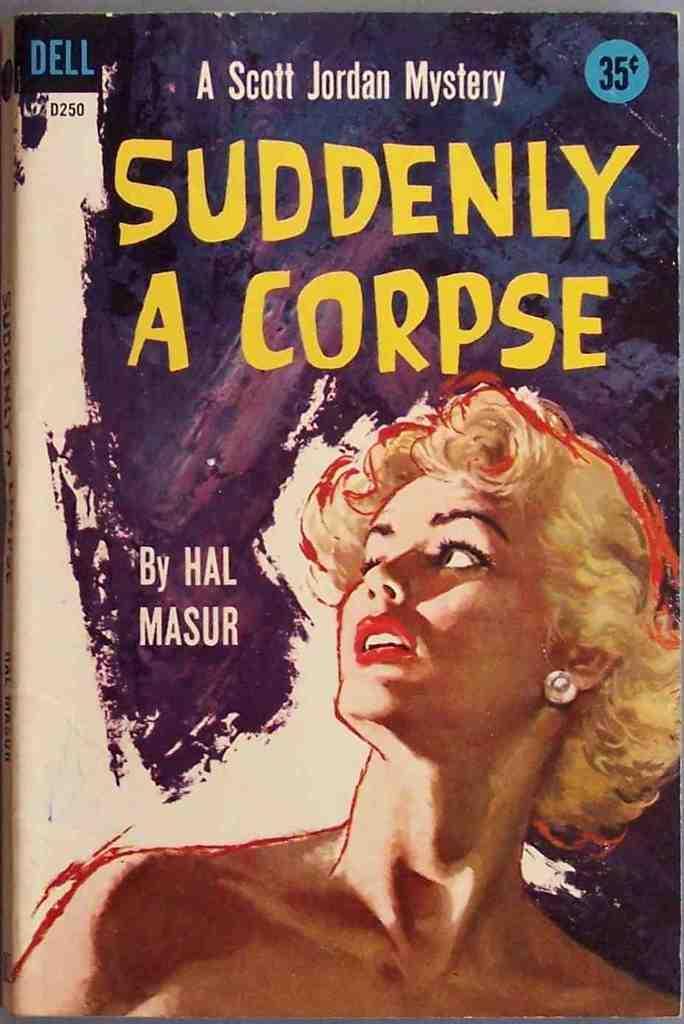Describe this image in one or two sentences. In this picture we can see a poster with some information. We can see a woman with the short hair. 